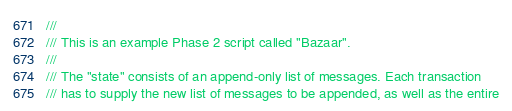Convert code to text. <code><loc_0><loc_0><loc_500><loc_500><_Rust_>///
/// This is an example Phase 2 script called "Bazaar".
///
/// The "state" consists of an append-only list of messages. Each transaction
/// has to supply the new list of messages to be appended, as well as the entire</code> 